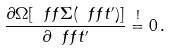<formula> <loc_0><loc_0><loc_500><loc_500>\frac { \partial \Omega [ \ f f \Sigma ( \ f f t ^ { \prime } ) ] } { \partial \ f f t ^ { \prime } } \stackrel { ! } { = } 0 \, .</formula> 